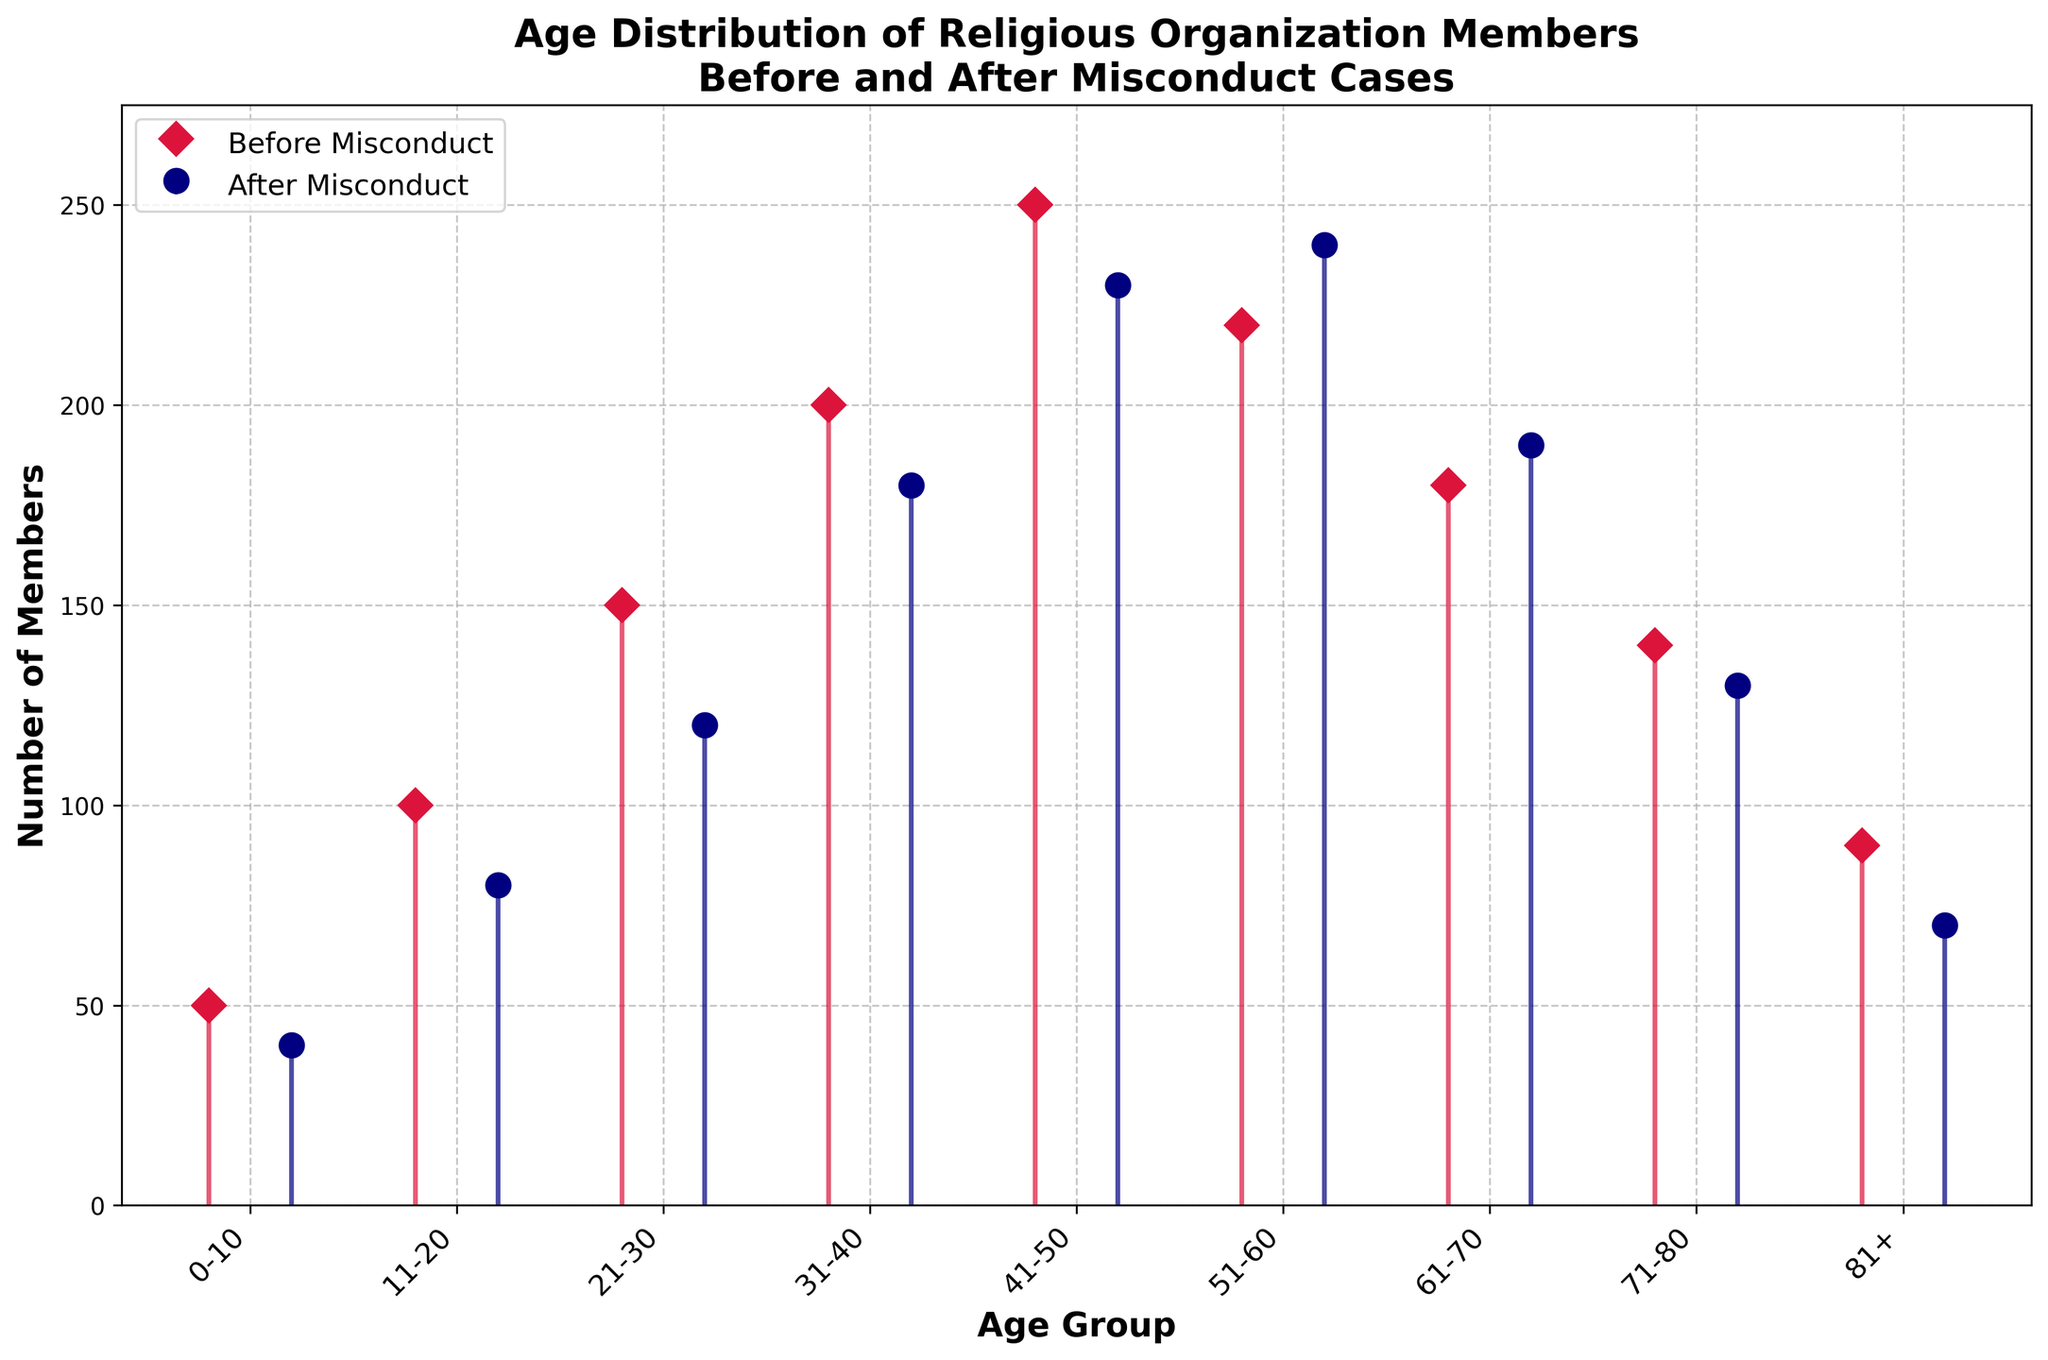What is the title of the figure? The title of the figure is located at the top of the plot. It summarizes the main topic of the plot, which is the age distribution of religious organization members before and after misconduct cases.
Answer: Age Distribution of Religious Organization Members Before and After Misconduct Cases What are the colors used to represent the data before and after the misconduct cases? The colors used in the legend indicate that one set of data points is in crimson while the other set is in navy. This helps in differentiating between 'Before Misconduct' and 'After Misconduct'.
Answer: Crimson and Navy Which age group experienced the largest decline in membership numbers after misconduct cases? By analyzing the stem lengths, the '21-30' age group has one of the largest differences between the crimson (Before Misconduct) and navy (After Misconduct) stems. Subtracting the ‘After Misconduct’ value (120) from the ‘Before Misconduct’ value (150) gives the decline in members, which is 30.
Answer: 21-30 In which age group did the number of members increase after the misconduct cases? By comparing the heights of the stems, the '51-60' age group has a longer navy colored stem (240) than crimson (220), indicating an increase of 20 members.
Answer: 51-60 What is the number of members in the '41-50' age group before and after the misconduct cases? The plot shows for the '41-50' age group, the height of the crimson stem is 250 and the height of the navy stem is 230.
Answer: 250 (Before Misconduct), 230 (After Misconduct) What is the total number of members before and after misconduct cases for age groups above 70? By summing the members from the '71-80' and '81+' age groups, before misconduct: 140 + 90 = 230, and after misconduct: 130 + 70 = 200.
Answer: 230 (Before Misconduct), 200 (After Misconduct) What is the average number of members in the age groups '0-10' and '11-20' after misconduct cases? The members in the '0-10' age group after misconduct is 40 and in the '11-20' age group is 80. Summing these and dividing by 2 gives (40+80)/2 = 60.
Answer: 60 Which age group has the smallest difference in membership numbers before and after misconduct cases? By analyzing the differences between stems, the '61-70' age group has a small difference between 'Before Misconduct' (180) and 'After Misconduct' (190), giving a difference of 10.
Answer: 61-70 Which age group had the highest number of members before the misconduct cases? By comparing the heights of the crimson stems, the '41-50' age group has the highest value at 250.
Answer: 41-50 By how much did the total membership change for the '31-40' age group after the misconduct cases? The 'Before Misconduct' value for the '31-40' age group is 200, and the 'After Misconduct' value is 180. The difference is 200 - 180, resulting in a decline of 20 members.
Answer: Declined by 20 members 